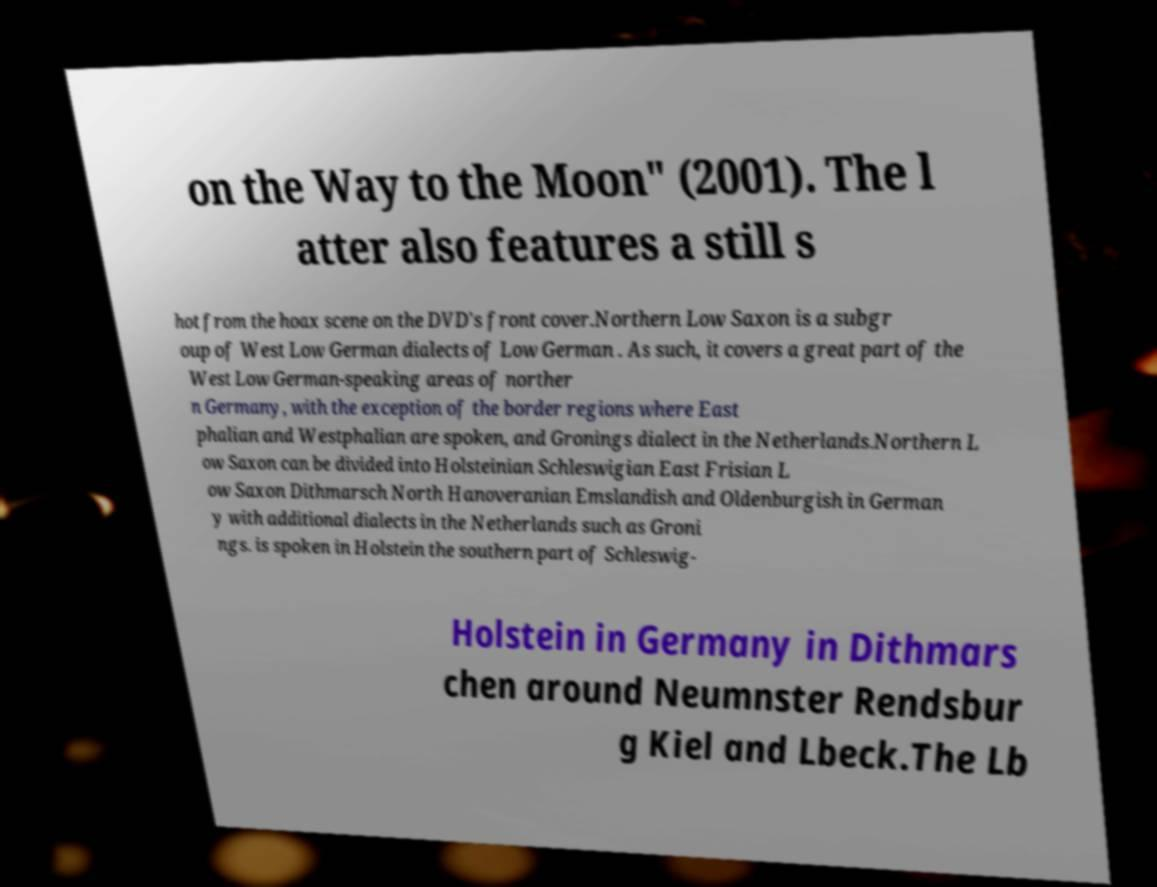Can you read and provide the text displayed in the image?This photo seems to have some interesting text. Can you extract and type it out for me? on the Way to the Moon" (2001). The l atter also features a still s hot from the hoax scene on the DVD's front cover.Northern Low Saxon is a subgr oup of West Low German dialects of Low German . As such, it covers a great part of the West Low German-speaking areas of norther n Germany, with the exception of the border regions where East phalian and Westphalian are spoken, and Gronings dialect in the Netherlands.Northern L ow Saxon can be divided into Holsteinian Schleswigian East Frisian L ow Saxon Dithmarsch North Hanoveranian Emslandish and Oldenburgish in German y with additional dialects in the Netherlands such as Groni ngs. is spoken in Holstein the southern part of Schleswig- Holstein in Germany in Dithmars chen around Neumnster Rendsbur g Kiel and Lbeck.The Lb 